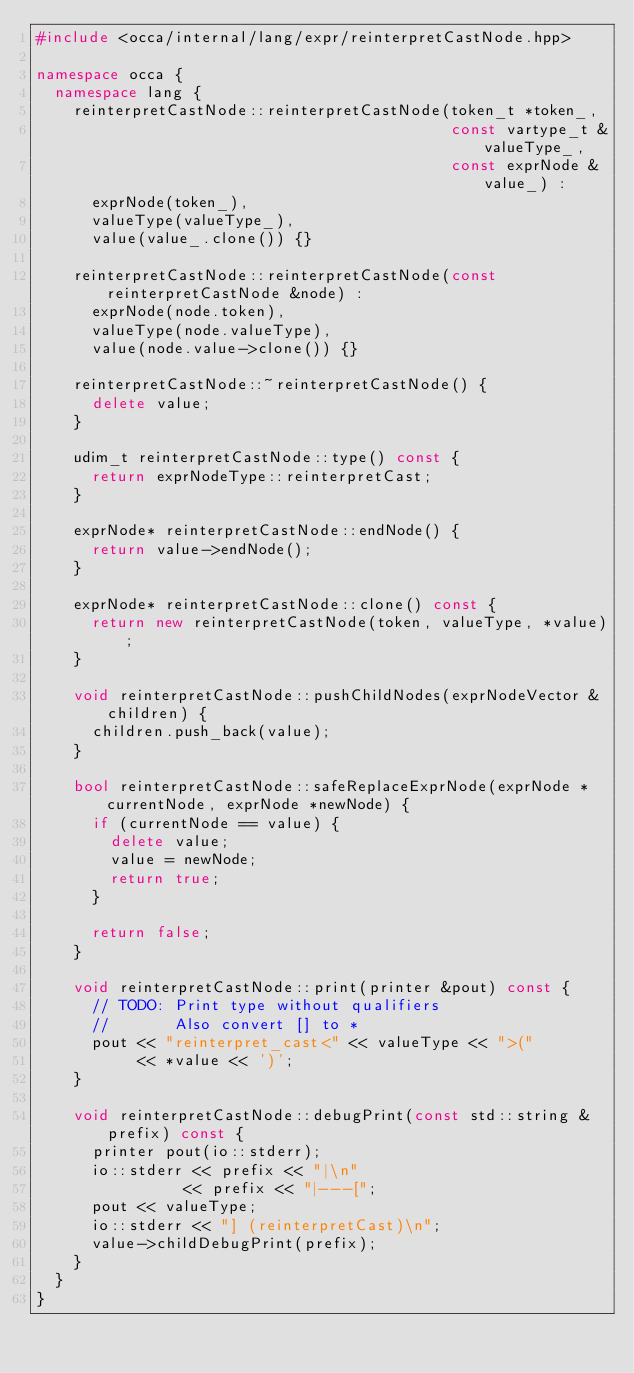<code> <loc_0><loc_0><loc_500><loc_500><_C++_>#include <occa/internal/lang/expr/reinterpretCastNode.hpp>

namespace occa {
  namespace lang {
    reinterpretCastNode::reinterpretCastNode(token_t *token_,
                                             const vartype_t &valueType_,
                                             const exprNode &value_) :
      exprNode(token_),
      valueType(valueType_),
      value(value_.clone()) {}

    reinterpretCastNode::reinterpretCastNode(const reinterpretCastNode &node) :
      exprNode(node.token),
      valueType(node.valueType),
      value(node.value->clone()) {}

    reinterpretCastNode::~reinterpretCastNode() {
      delete value;
    }

    udim_t reinterpretCastNode::type() const {
      return exprNodeType::reinterpretCast;
    }

    exprNode* reinterpretCastNode::endNode() {
      return value->endNode();
    }

    exprNode* reinterpretCastNode::clone() const {
      return new reinterpretCastNode(token, valueType, *value);
    }

    void reinterpretCastNode::pushChildNodes(exprNodeVector &children) {
      children.push_back(value);
    }

    bool reinterpretCastNode::safeReplaceExprNode(exprNode *currentNode, exprNode *newNode) {
      if (currentNode == value) {
        delete value;
        value = newNode;
        return true;
      }

      return false;
    }

    void reinterpretCastNode::print(printer &pout) const {
      // TODO: Print type without qualifiers
      //       Also convert [] to *
      pout << "reinterpret_cast<" << valueType << ">("
           << *value << ')';
    }

    void reinterpretCastNode::debugPrint(const std::string &prefix) const {
      printer pout(io::stderr);
      io::stderr << prefix << "|\n"
                << prefix << "|---[";
      pout << valueType;
      io::stderr << "] (reinterpretCast)\n";
      value->childDebugPrint(prefix);
    }
  }
}
</code> 